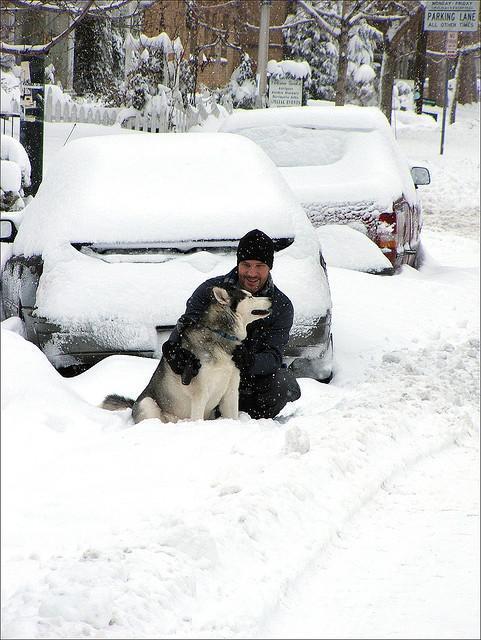This animal is the same species as what character on Game of Thrones?
From the following four choices, select the correct answer to address the question.
Options: Hot pie, ghost, hound, mountain. Ghost. 